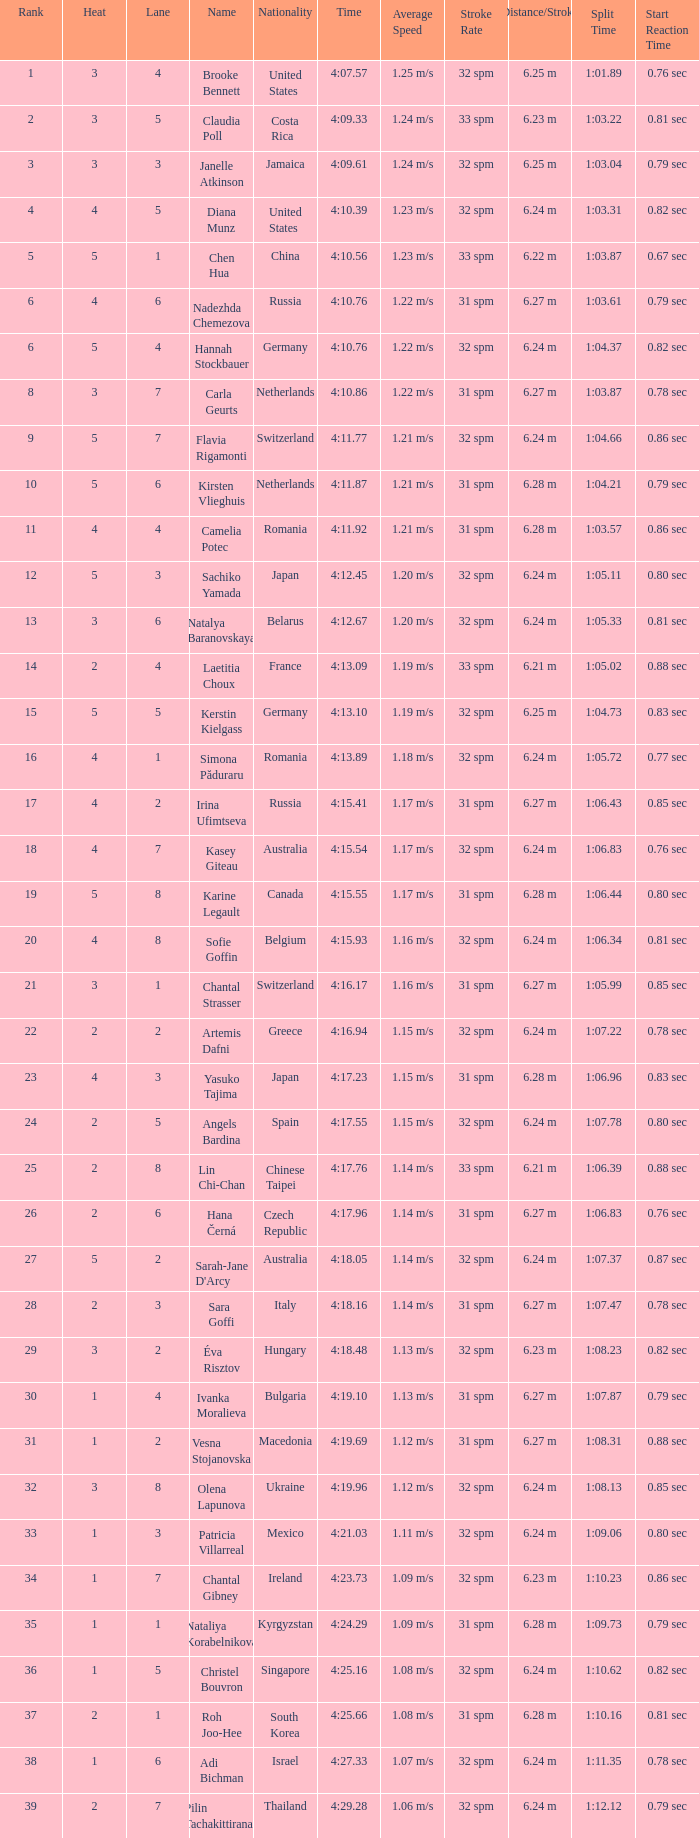I'm looking to parse the entire table for insights. Could you assist me with that? {'header': ['Rank', 'Heat', 'Lane', 'Name', 'Nationality', 'Time', 'Average Speed', 'Stroke Rate', 'Distance/Stroke', 'Split Time', 'Start Reaction Time'], 'rows': [['1', '3', '4', 'Brooke Bennett', 'United States', '4:07.57', '1.25 m/s', '32 spm', '6.25 m', '1:01.89', '0.76 sec'], ['2', '3', '5', 'Claudia Poll', 'Costa Rica', '4:09.33', '1.24 m/s', '33 spm', '6.23 m', '1:03.22', '0.81 sec'], ['3', '3', '3', 'Janelle Atkinson', 'Jamaica', '4:09.61', '1.24 m/s', '32 spm', '6.25 m', '1:03.04', '0.79 sec'], ['4', '4', '5', 'Diana Munz', 'United States', '4:10.39', '1.23 m/s', '32 spm', '6.24 m', '1:03.31', '0.82 sec'], ['5', '5', '1', 'Chen Hua', 'China', '4:10.56', '1.23 m/s', '33 spm', '6.22 m', '1:03.87', '0.67 sec'], ['6', '4', '6', 'Nadezhda Chemezova', 'Russia', '4:10.76', '1.22 m/s', '31 spm', '6.27 m', '1:03.61', '0.79 sec'], ['6', '5', '4', 'Hannah Stockbauer', 'Germany', '4:10.76', '1.22 m/s', '32 spm', '6.24 m', '1:04.37', '0.82 sec'], ['8', '3', '7', 'Carla Geurts', 'Netherlands', '4:10.86', '1.22 m/s', '31 spm', '6.27 m', '1:03.87', '0.78 sec'], ['9', '5', '7', 'Flavia Rigamonti', 'Switzerland', '4:11.77', '1.21 m/s', '32 spm', '6.24 m', '1:04.66', '0.86 sec'], ['10', '5', '6', 'Kirsten Vlieghuis', 'Netherlands', '4:11.87', '1.21 m/s', '31 spm', '6.28 m', '1:04.21', '0.79 sec'], ['11', '4', '4', 'Camelia Potec', 'Romania', '4:11.92', '1.21 m/s', '31 spm', '6.28 m', '1:03.57', '0.86 sec'], ['12', '5', '3', 'Sachiko Yamada', 'Japan', '4:12.45', '1.20 m/s', '32 spm', '6.24 m', '1:05.11', '0.80 sec'], ['13', '3', '6', 'Natalya Baranovskaya', 'Belarus', '4:12.67', '1.20 m/s', '32 spm', '6.24 m', '1:05.33', '0.81 sec'], ['14', '2', '4', 'Laetitia Choux', 'France', '4:13.09', '1.19 m/s', '33 spm', '6.21 m', '1:05.02', '0.88 sec'], ['15', '5', '5', 'Kerstin Kielgass', 'Germany', '4:13.10', '1.19 m/s', '32 spm', '6.25 m', '1:04.73', '0.83 sec'], ['16', '4', '1', 'Simona Păduraru', 'Romania', '4:13.89', '1.18 m/s', '32 spm', '6.24 m', '1:05.72', '0.77 sec'], ['17', '4', '2', 'Irina Ufimtseva', 'Russia', '4:15.41', '1.17 m/s', '31 spm', '6.27 m', '1:06.43', '0.85 sec'], ['18', '4', '7', 'Kasey Giteau', 'Australia', '4:15.54', '1.17 m/s', '32 spm', '6.24 m', '1:06.83', '0.76 sec'], ['19', '5', '8', 'Karine Legault', 'Canada', '4:15.55', '1.17 m/s', '31 spm', '6.28 m', '1:06.44', '0.80 sec'], ['20', '4', '8', 'Sofie Goffin', 'Belgium', '4:15.93', '1.16 m/s', '32 spm', '6.24 m', '1:06.34', '0.81 sec'], ['21', '3', '1', 'Chantal Strasser', 'Switzerland', '4:16.17', '1.16 m/s', '31 spm', '6.27 m', '1:05.99', '0.85 sec'], ['22', '2', '2', 'Artemis Dafni', 'Greece', '4:16.94', '1.15 m/s', '32 spm', '6.24 m', '1:07.22', '0.78 sec'], ['23', '4', '3', 'Yasuko Tajima', 'Japan', '4:17.23', '1.15 m/s', '31 spm', '6.28 m', '1:06.96', '0.83 sec'], ['24', '2', '5', 'Angels Bardina', 'Spain', '4:17.55', '1.15 m/s', '32 spm', '6.24 m', '1:07.78', '0.80 sec'], ['25', '2', '8', 'Lin Chi-Chan', 'Chinese Taipei', '4:17.76', '1.14 m/s', '33 spm', '6.21 m', '1:06.39', '0.88 sec'], ['26', '2', '6', 'Hana Černá', 'Czech Republic', '4:17.96', '1.14 m/s', '31 spm', '6.27 m', '1:06.83', '0.76 sec'], ['27', '5', '2', "Sarah-Jane D'Arcy", 'Australia', '4:18.05', '1.14 m/s', '32 spm', '6.24 m', '1:07.37', '0.87 sec'], ['28', '2', '3', 'Sara Goffi', 'Italy', '4:18.16', '1.14 m/s', '31 spm', '6.27 m', '1:07.47', '0.78 sec'], ['29', '3', '2', 'Éva Risztov', 'Hungary', '4:18.48', '1.13 m/s', '32 spm', '6.23 m', '1:08.23', '0.82 sec'], ['30', '1', '4', 'Ivanka Moralieva', 'Bulgaria', '4:19.10', '1.13 m/s', '31 spm', '6.27 m', '1:07.87', '0.79 sec'], ['31', '1', '2', 'Vesna Stojanovska', 'Macedonia', '4:19.69', '1.12 m/s', '31 spm', '6.27 m', '1:08.31', '0.88 sec'], ['32', '3', '8', 'Olena Lapunova', 'Ukraine', '4:19.96', '1.12 m/s', '32 spm', '6.24 m', '1:08.13', '0.85 sec'], ['33', '1', '3', 'Patricia Villarreal', 'Mexico', '4:21.03', '1.11 m/s', '32 spm', '6.24 m', '1:09.06', '0.80 sec'], ['34', '1', '7', 'Chantal Gibney', 'Ireland', '4:23.73', '1.09 m/s', '32 spm', '6.23 m', '1:10.23', '0.86 sec'], ['35', '1', '1', 'Nataliya Korabelnikova', 'Kyrgyzstan', '4:24.29', '1.09 m/s', '31 spm', '6.28 m', '1:09.73', '0.79 sec'], ['36', '1', '5', 'Christel Bouvron', 'Singapore', '4:25.16', '1.08 m/s', '32 spm', '6.24 m', '1:10.62', '0.82 sec'], ['37', '2', '1', 'Roh Joo-Hee', 'South Korea', '4:25.66', '1.08 m/s', '31 spm', '6.28 m', '1:10.16', '0.81 sec'], ['38', '1', '6', 'Adi Bichman', 'Israel', '4:27.33', '1.07 m/s', '32 spm', '6.24 m', '1:11.35', '0.78 sec'], ['39', '2', '7', 'Pilin Tachakittiranan', 'Thailand', '4:29.28', '1.06 m/s', '32 spm', '6.24 m', '1:12.12', '0.79 sec']]} Name the total number of lane for brooke bennett and rank less than 1 0.0. 